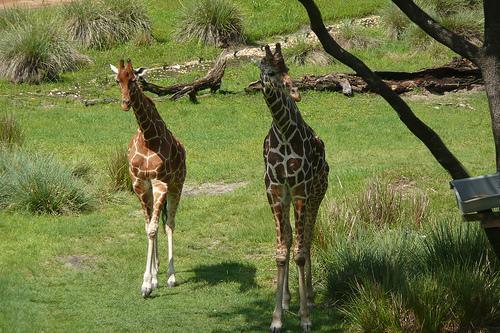How many giraffes?
Give a very brief answer. 2. 